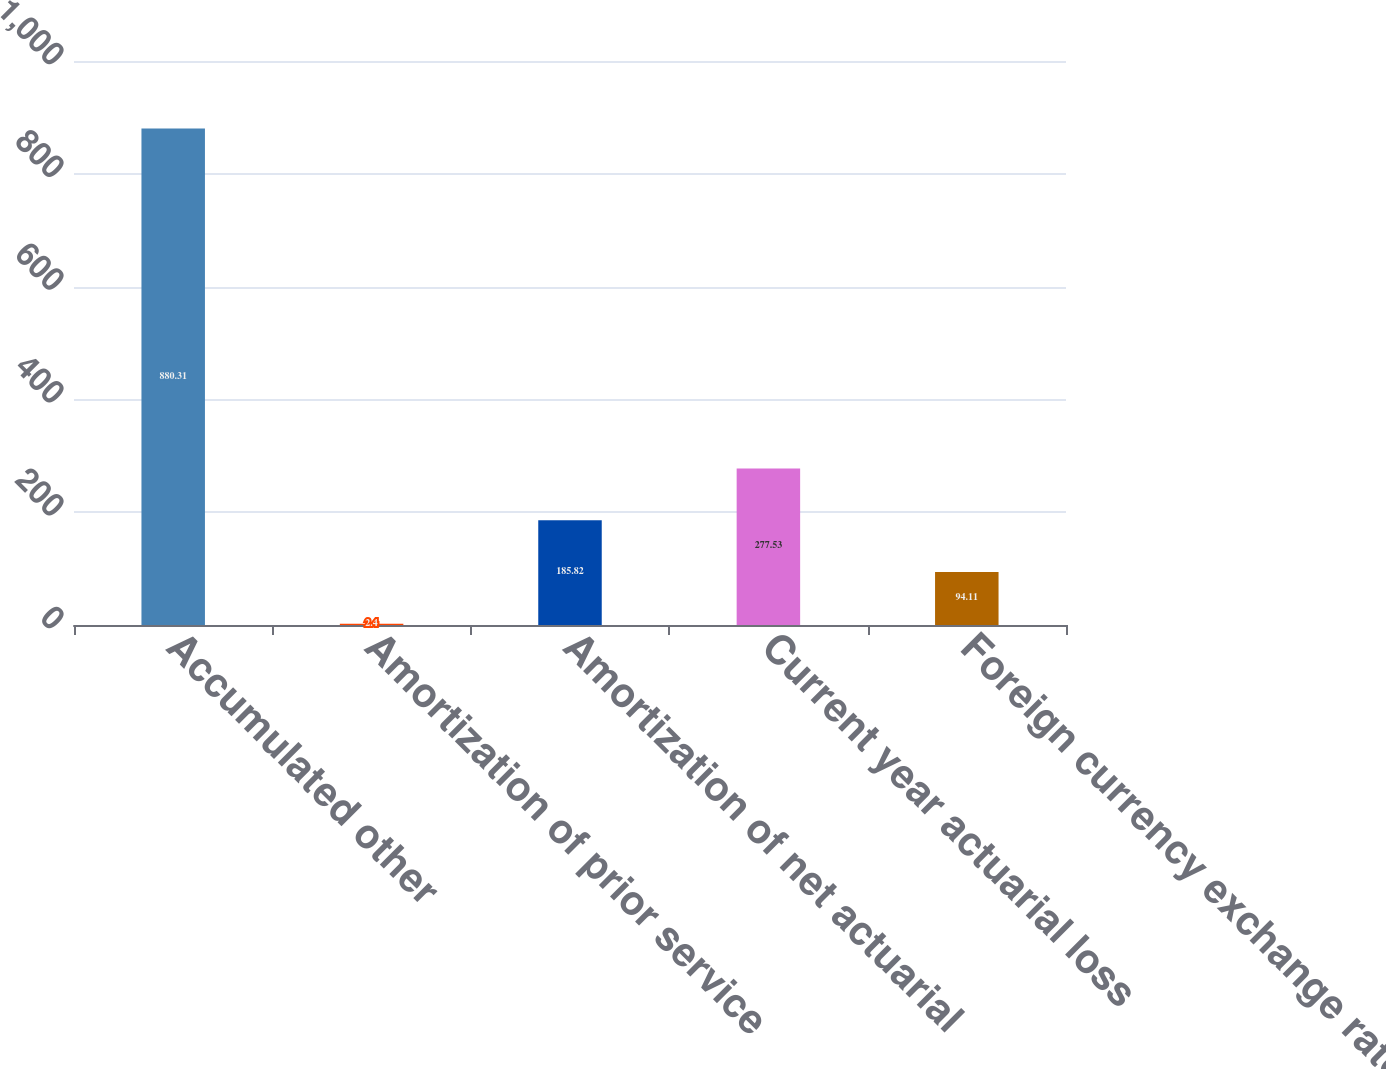Convert chart. <chart><loc_0><loc_0><loc_500><loc_500><bar_chart><fcel>Accumulated other<fcel>Amortization of prior service<fcel>Amortization of net actuarial<fcel>Current year actuarial loss<fcel>Foreign currency exchange rate<nl><fcel>880.31<fcel>2.4<fcel>185.82<fcel>277.53<fcel>94.11<nl></chart> 